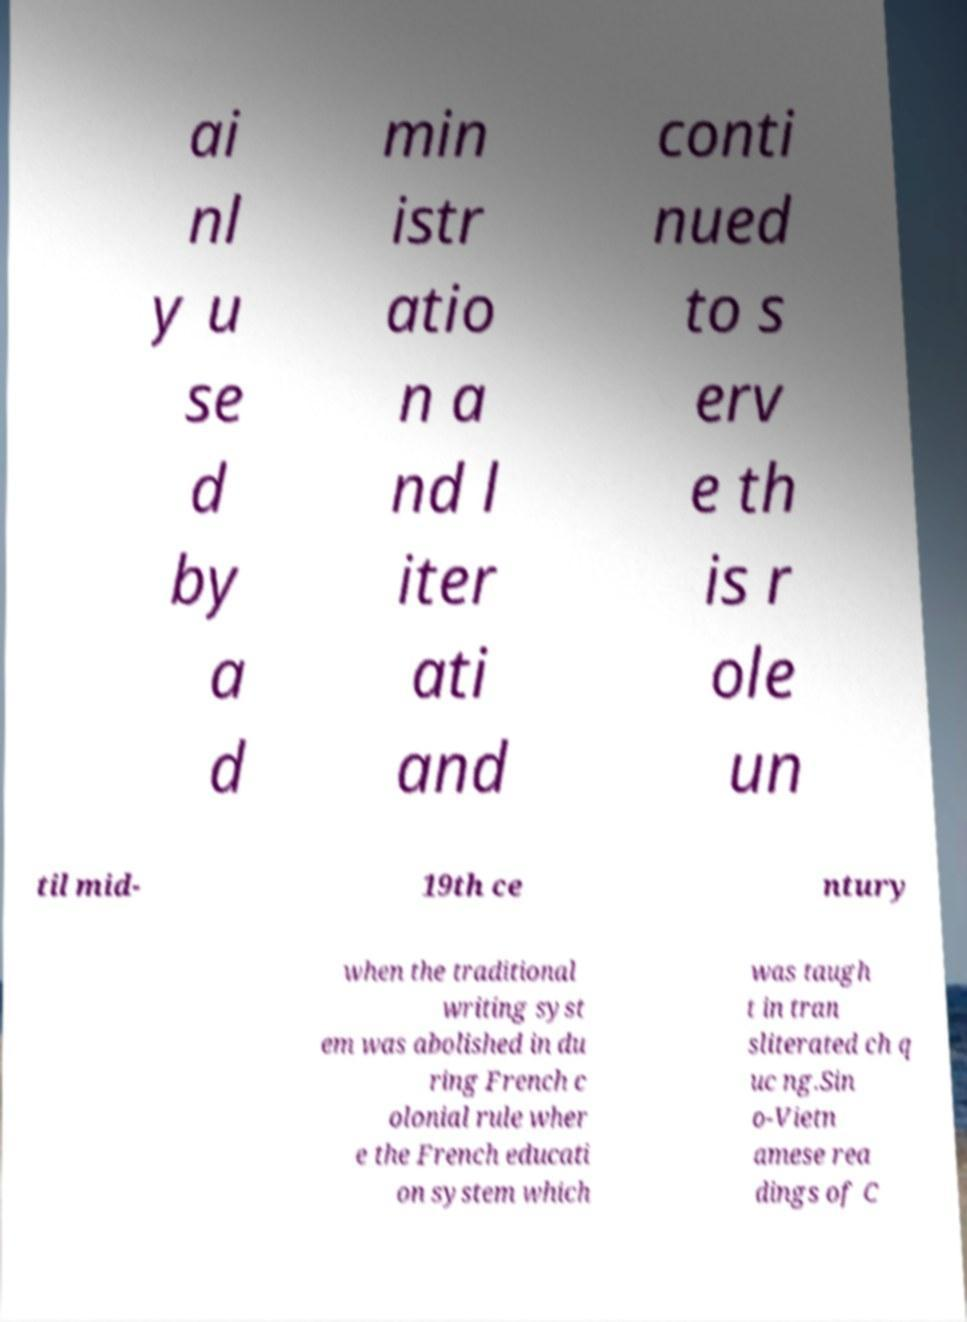Please read and relay the text visible in this image. What does it say? ai nl y u se d by a d min istr atio n a nd l iter ati and conti nued to s erv e th is r ole un til mid- 19th ce ntury when the traditional writing syst em was abolished in du ring French c olonial rule wher e the French educati on system which was taugh t in tran sliterated ch q uc ng.Sin o-Vietn amese rea dings of C 